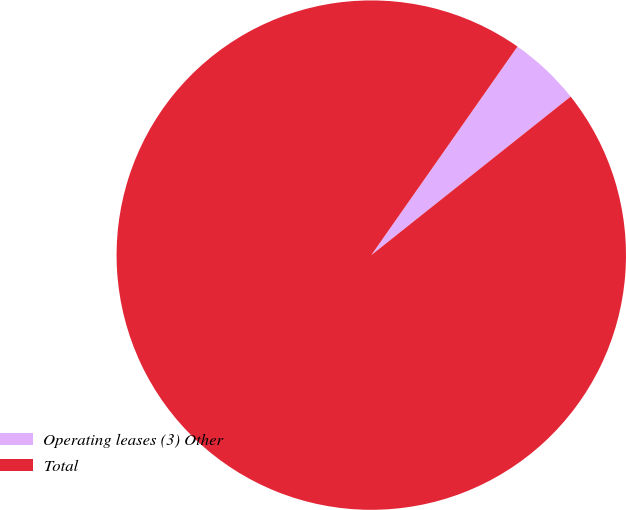Convert chart to OTSL. <chart><loc_0><loc_0><loc_500><loc_500><pie_chart><fcel>Operating leases (3) Other<fcel>Total<nl><fcel>4.58%<fcel>95.42%<nl></chart> 